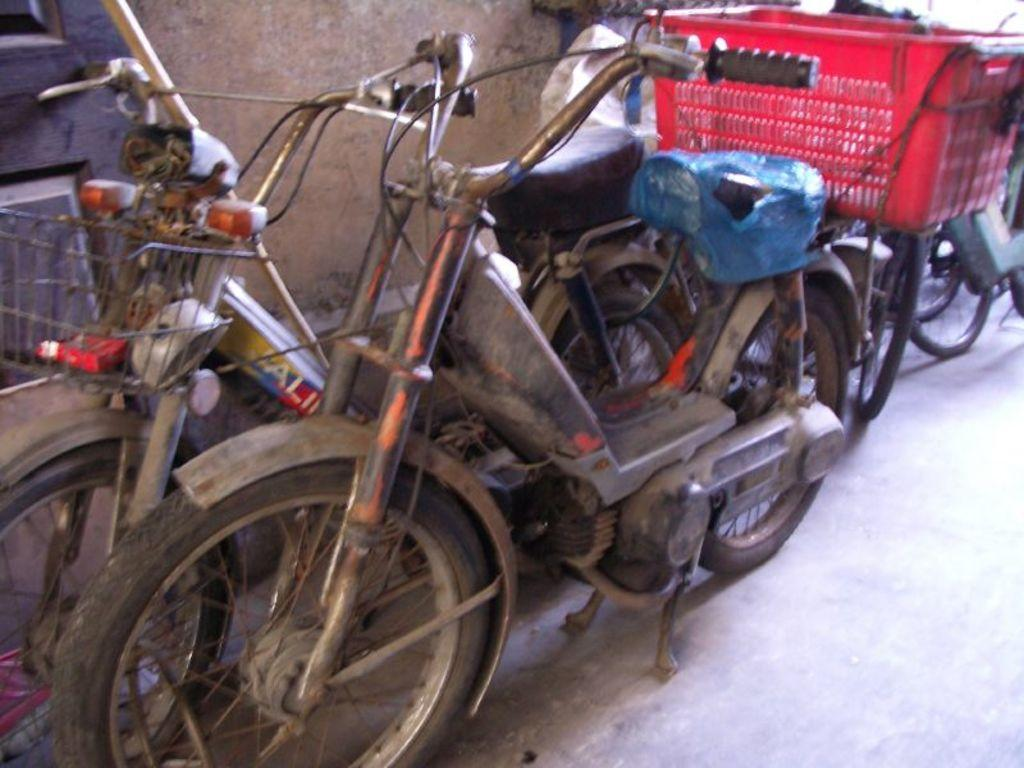What types of vehicles can be seen in the image? There are vehicles visible on the surface in the image. What is the color of the basket in the image? The basket in the image is red. What is covering something in the image? There is a cover in the image. What material is the wooden object made of in the image? The wooden object in the image is made of wood. What type of structure can be seen in the image? There is a wall in the image. How many police officers are present in the image? There are no police officers present in the image. What type of wood is used to make the truck in the image? There is no truck present in the image, so it is not possible to determine the type of wood used. 